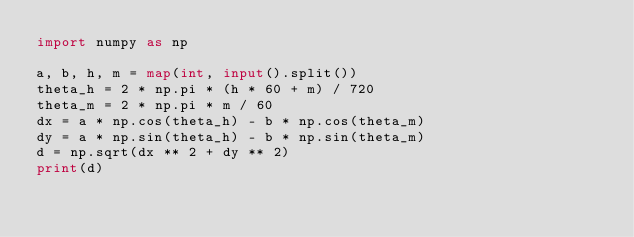<code> <loc_0><loc_0><loc_500><loc_500><_Python_>import numpy as np

a, b, h, m = map(int, input().split())
theta_h = 2 * np.pi * (h * 60 + m) / 720
theta_m = 2 * np.pi * m / 60
dx = a * np.cos(theta_h) - b * np.cos(theta_m)
dy = a * np.sin(theta_h) - b * np.sin(theta_m)
d = np.sqrt(dx ** 2 + dy ** 2)
print(d)
</code> 